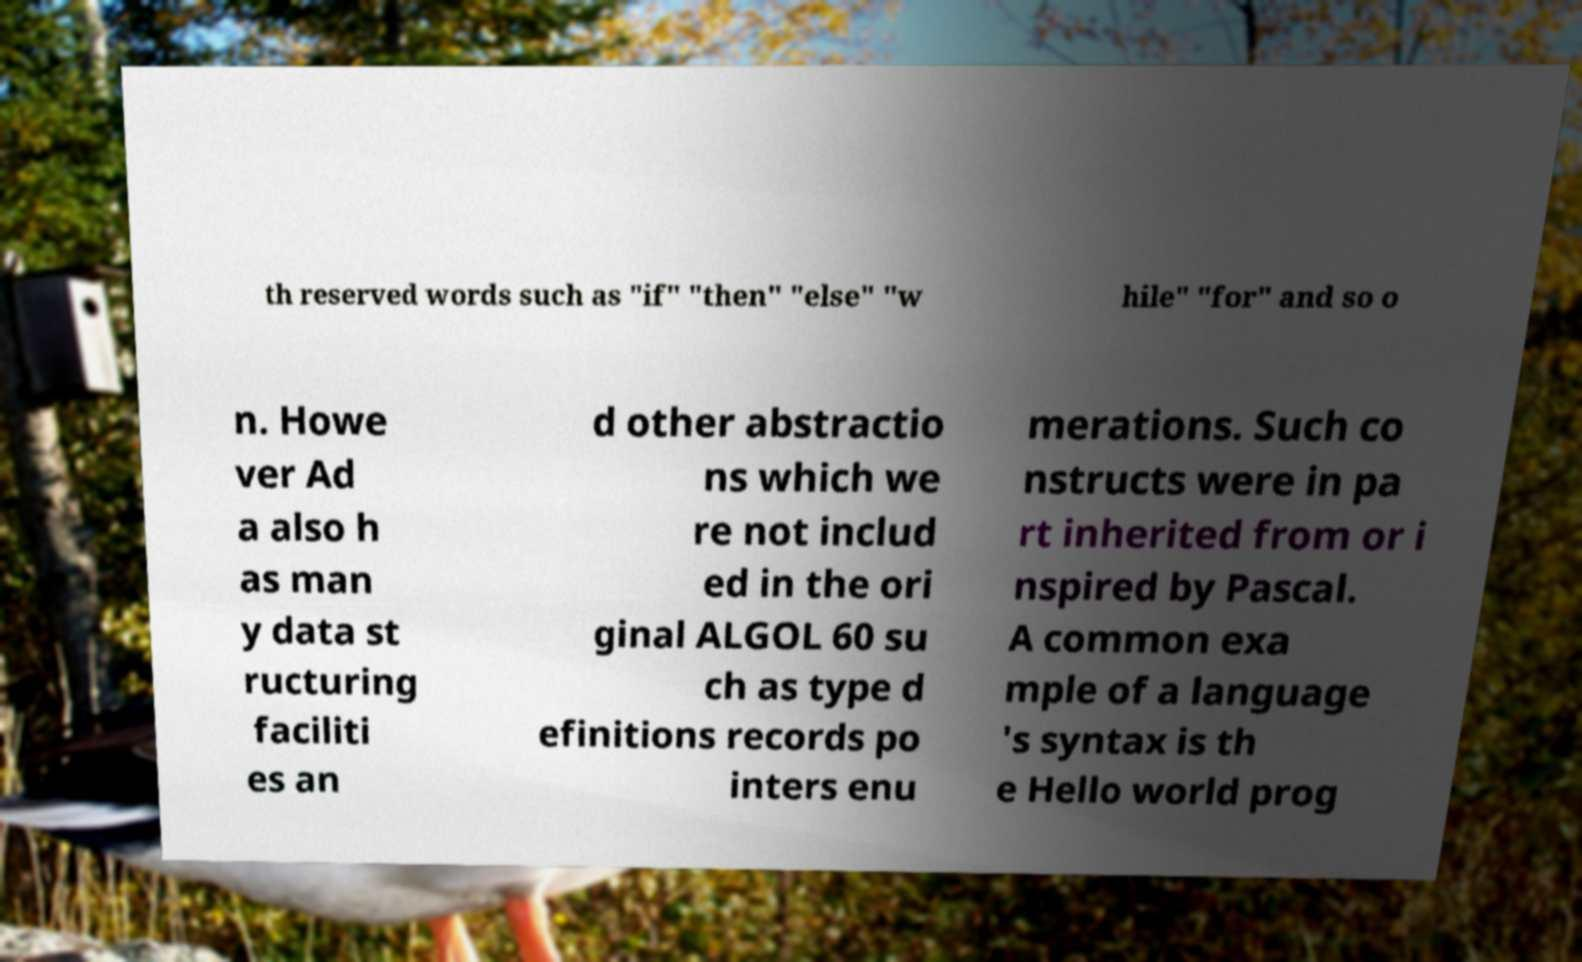There's text embedded in this image that I need extracted. Can you transcribe it verbatim? th reserved words such as "if" "then" "else" "w hile" "for" and so o n. Howe ver Ad a also h as man y data st ructuring faciliti es an d other abstractio ns which we re not includ ed in the ori ginal ALGOL 60 su ch as type d efinitions records po inters enu merations. Such co nstructs were in pa rt inherited from or i nspired by Pascal. A common exa mple of a language 's syntax is th e Hello world prog 